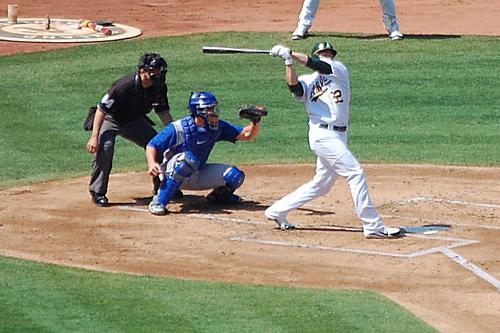Did the player hit the ball?
Quick response, please. No. How many legs can you see in the photo?
Quick response, please. 8. Is the player Left-handed?
Quick response, please. Yes. Is the batter touching home plate?
Write a very short answer. No. 